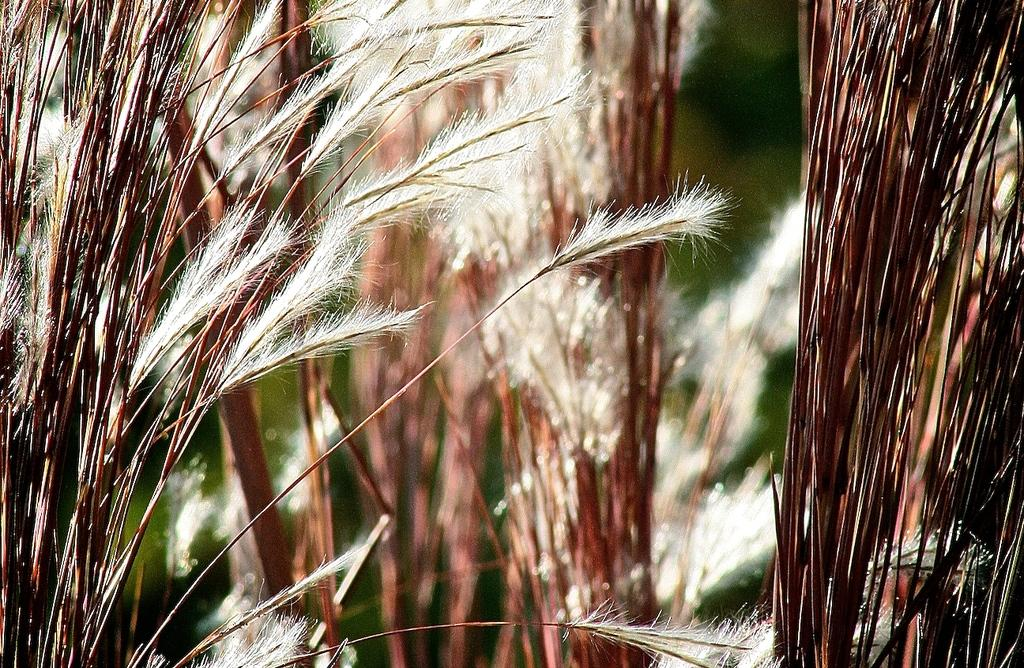What is the main subject of the image? The main subject of the image is a group of plants. Can you tell me how many judges are present in the image? There are no judges present in the image; it features a group of plants. What type of alarm is depicted among the plants in the image? There is no alarm present among the plants in the image; it features a group of plants. 